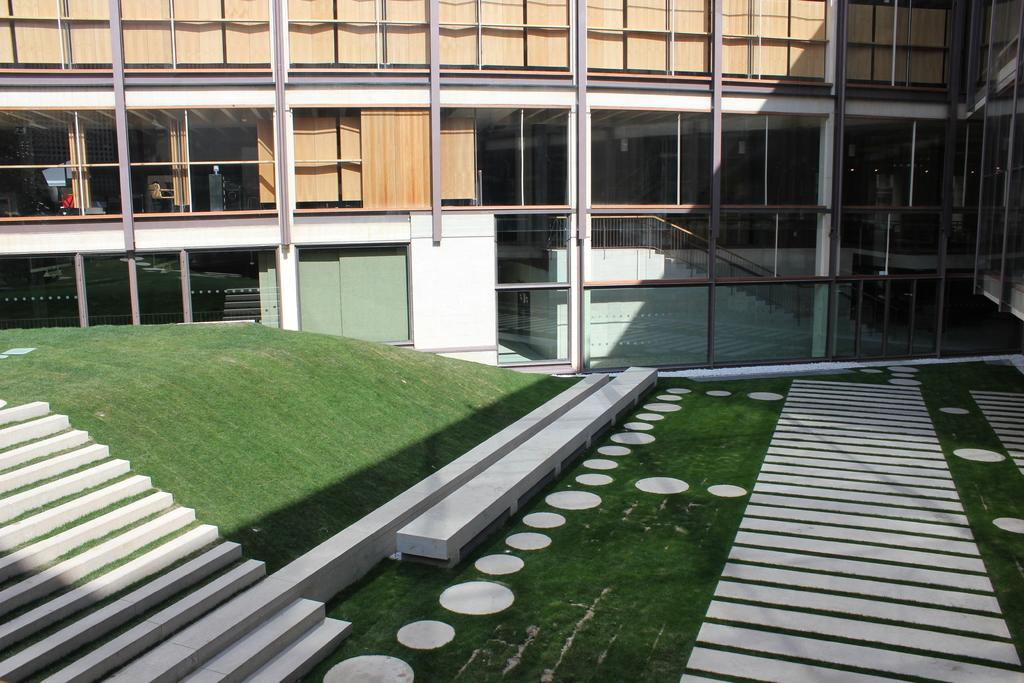What can be seen on the left side of the image? There are stairs on the left side of the image. What is the surface on which the stairs are located? The stairs are on the surface of the grass. grass. What is visible in the background of the image? There is a building in the background of the image. What is the name of the cheese that is being used to construct the stairs in the image? There is no cheese present in the image, and the stairs are not made of cheese. 